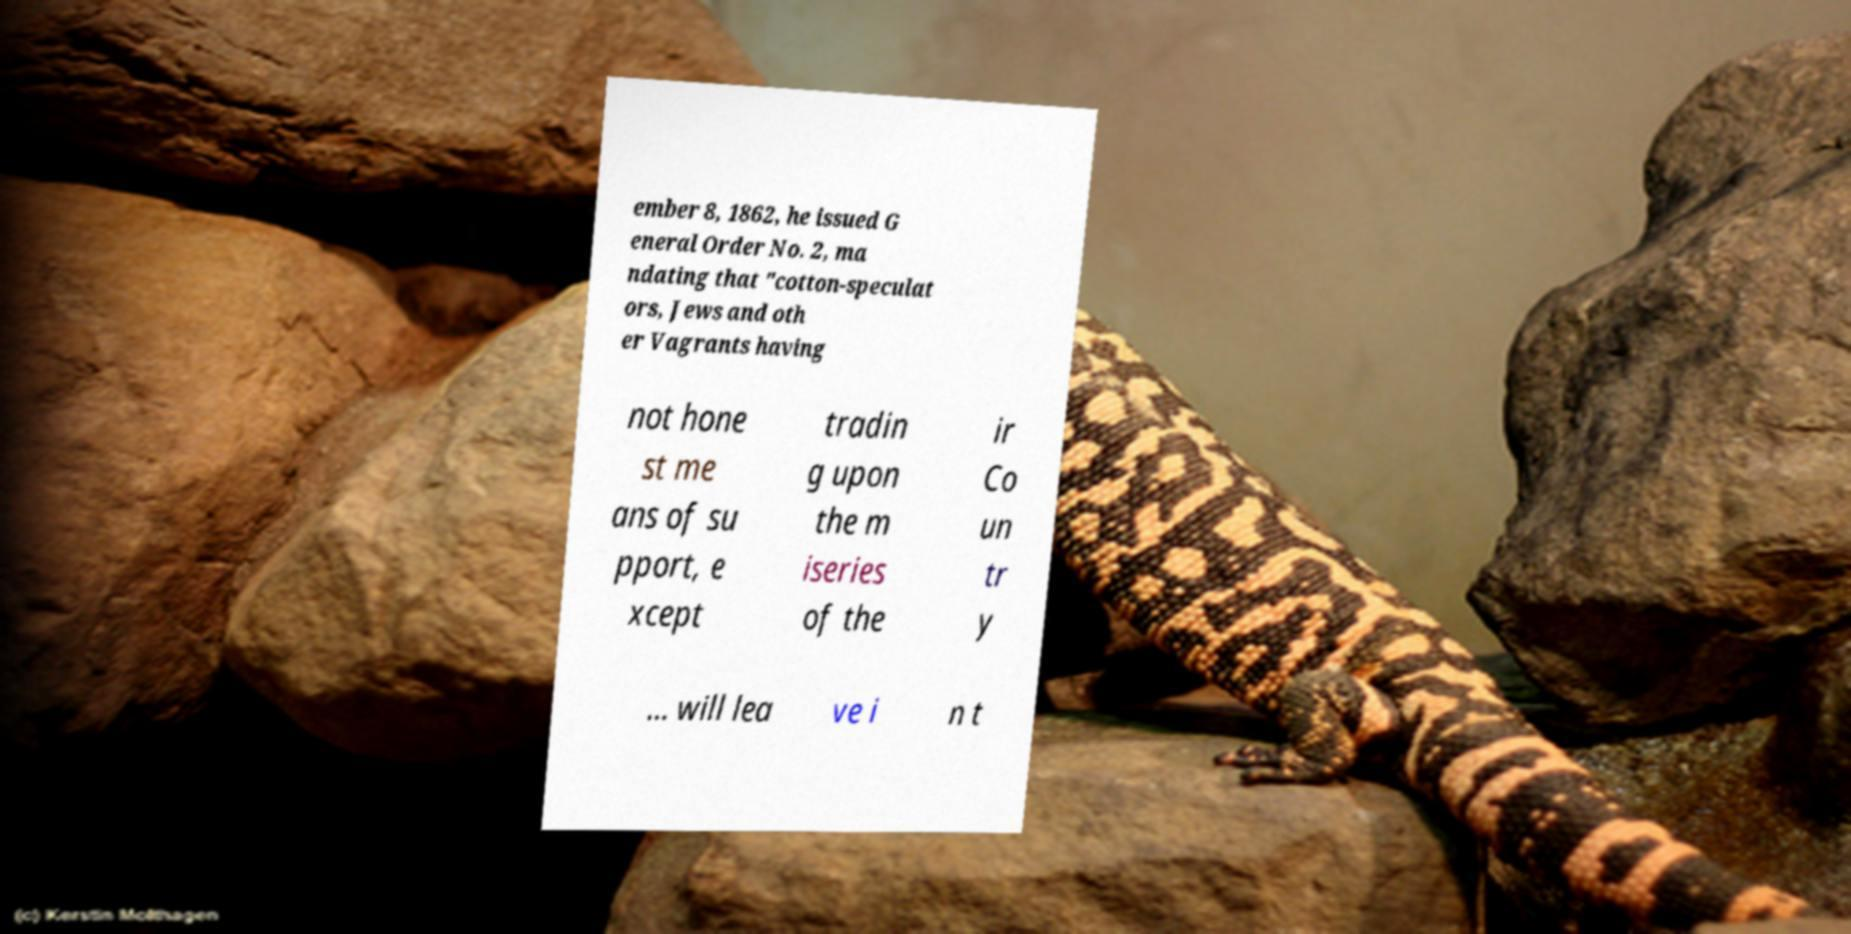Could you extract and type out the text from this image? ember 8, 1862, he issued G eneral Order No. 2, ma ndating that "cotton-speculat ors, Jews and oth er Vagrants having not hone st me ans of su pport, e xcept tradin g upon the m iseries of the ir Co un tr y … will lea ve i n t 